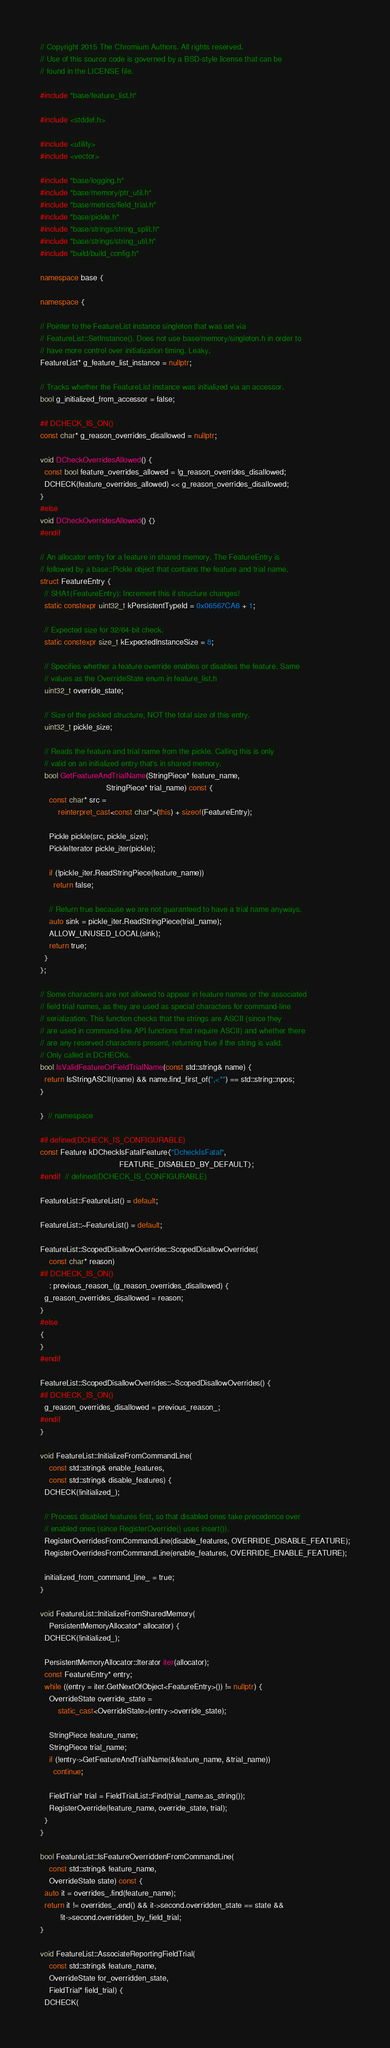Convert code to text. <code><loc_0><loc_0><loc_500><loc_500><_C++_>// Copyright 2015 The Chromium Authors. All rights reserved.
// Use of this source code is governed by a BSD-style license that can be
// found in the LICENSE file.

#include "base/feature_list.h"

#include <stddef.h>

#include <utility>
#include <vector>

#include "base/logging.h"
#include "base/memory/ptr_util.h"
#include "base/metrics/field_trial.h"
#include "base/pickle.h"
#include "base/strings/string_split.h"
#include "base/strings/string_util.h"
#include "build/build_config.h"

namespace base {

namespace {

// Pointer to the FeatureList instance singleton that was set via
// FeatureList::SetInstance(). Does not use base/memory/singleton.h in order to
// have more control over initialization timing. Leaky.
FeatureList* g_feature_list_instance = nullptr;

// Tracks whether the FeatureList instance was initialized via an accessor.
bool g_initialized_from_accessor = false;

#if DCHECK_IS_ON()
const char* g_reason_overrides_disallowed = nullptr;

void DCheckOverridesAllowed() {
  const bool feature_overrides_allowed = !g_reason_overrides_disallowed;
  DCHECK(feature_overrides_allowed) << g_reason_overrides_disallowed;
}
#else
void DCheckOverridesAllowed() {}
#endif

// An allocator entry for a feature in shared memory. The FeatureEntry is
// followed by a base::Pickle object that contains the feature and trial name.
struct FeatureEntry {
  // SHA1(FeatureEntry): Increment this if structure changes!
  static constexpr uint32_t kPersistentTypeId = 0x06567CA6 + 1;

  // Expected size for 32/64-bit check.
  static constexpr size_t kExpectedInstanceSize = 8;

  // Specifies whether a feature override enables or disables the feature. Same
  // values as the OverrideState enum in feature_list.h
  uint32_t override_state;

  // Size of the pickled structure, NOT the total size of this entry.
  uint32_t pickle_size;

  // Reads the feature and trial name from the pickle. Calling this is only
  // valid on an initialized entry that's in shared memory.
  bool GetFeatureAndTrialName(StringPiece* feature_name,
                              StringPiece* trial_name) const {
    const char* src =
        reinterpret_cast<const char*>(this) + sizeof(FeatureEntry);

    Pickle pickle(src, pickle_size);
    PickleIterator pickle_iter(pickle);

    if (!pickle_iter.ReadStringPiece(feature_name))
      return false;

    // Return true because we are not guaranteed to have a trial name anyways.
    auto sink = pickle_iter.ReadStringPiece(trial_name);
    ALLOW_UNUSED_LOCAL(sink);
    return true;
  }
};

// Some characters are not allowed to appear in feature names or the associated
// field trial names, as they are used as special characters for command-line
// serialization. This function checks that the strings are ASCII (since they
// are used in command-line API functions that require ASCII) and whether there
// are any reserved characters present, returning true if the string is valid.
// Only called in DCHECKs.
bool IsValidFeatureOrFieldTrialName(const std::string& name) {
  return IsStringASCII(name) && name.find_first_of(",<*") == std::string::npos;
}

}  // namespace

#if defined(DCHECK_IS_CONFIGURABLE)
const Feature kDCheckIsFatalFeature{"DcheckIsFatal",
                                    FEATURE_DISABLED_BY_DEFAULT};
#endif  // defined(DCHECK_IS_CONFIGURABLE)

FeatureList::FeatureList() = default;

FeatureList::~FeatureList() = default;

FeatureList::ScopedDisallowOverrides::ScopedDisallowOverrides(
    const char* reason)
#if DCHECK_IS_ON()
    : previous_reason_(g_reason_overrides_disallowed) {
  g_reason_overrides_disallowed = reason;
}
#else
{
}
#endif

FeatureList::ScopedDisallowOverrides::~ScopedDisallowOverrides() {
#if DCHECK_IS_ON()
  g_reason_overrides_disallowed = previous_reason_;
#endif
}

void FeatureList::InitializeFromCommandLine(
    const std::string& enable_features,
    const std::string& disable_features) {
  DCHECK(!initialized_);

  // Process disabled features first, so that disabled ones take precedence over
  // enabled ones (since RegisterOverride() uses insert()).
  RegisterOverridesFromCommandLine(disable_features, OVERRIDE_DISABLE_FEATURE);
  RegisterOverridesFromCommandLine(enable_features, OVERRIDE_ENABLE_FEATURE);

  initialized_from_command_line_ = true;
}

void FeatureList::InitializeFromSharedMemory(
    PersistentMemoryAllocator* allocator) {
  DCHECK(!initialized_);

  PersistentMemoryAllocator::Iterator iter(allocator);
  const FeatureEntry* entry;
  while ((entry = iter.GetNextOfObject<FeatureEntry>()) != nullptr) {
    OverrideState override_state =
        static_cast<OverrideState>(entry->override_state);

    StringPiece feature_name;
    StringPiece trial_name;
    if (!entry->GetFeatureAndTrialName(&feature_name, &trial_name))
      continue;

    FieldTrial* trial = FieldTrialList::Find(trial_name.as_string());
    RegisterOverride(feature_name, override_state, trial);
  }
}

bool FeatureList::IsFeatureOverriddenFromCommandLine(
    const std::string& feature_name,
    OverrideState state) const {
  auto it = overrides_.find(feature_name);
  return it != overrides_.end() && it->second.overridden_state == state &&
         !it->second.overridden_by_field_trial;
}

void FeatureList::AssociateReportingFieldTrial(
    const std::string& feature_name,
    OverrideState for_overridden_state,
    FieldTrial* field_trial) {
  DCHECK(</code> 